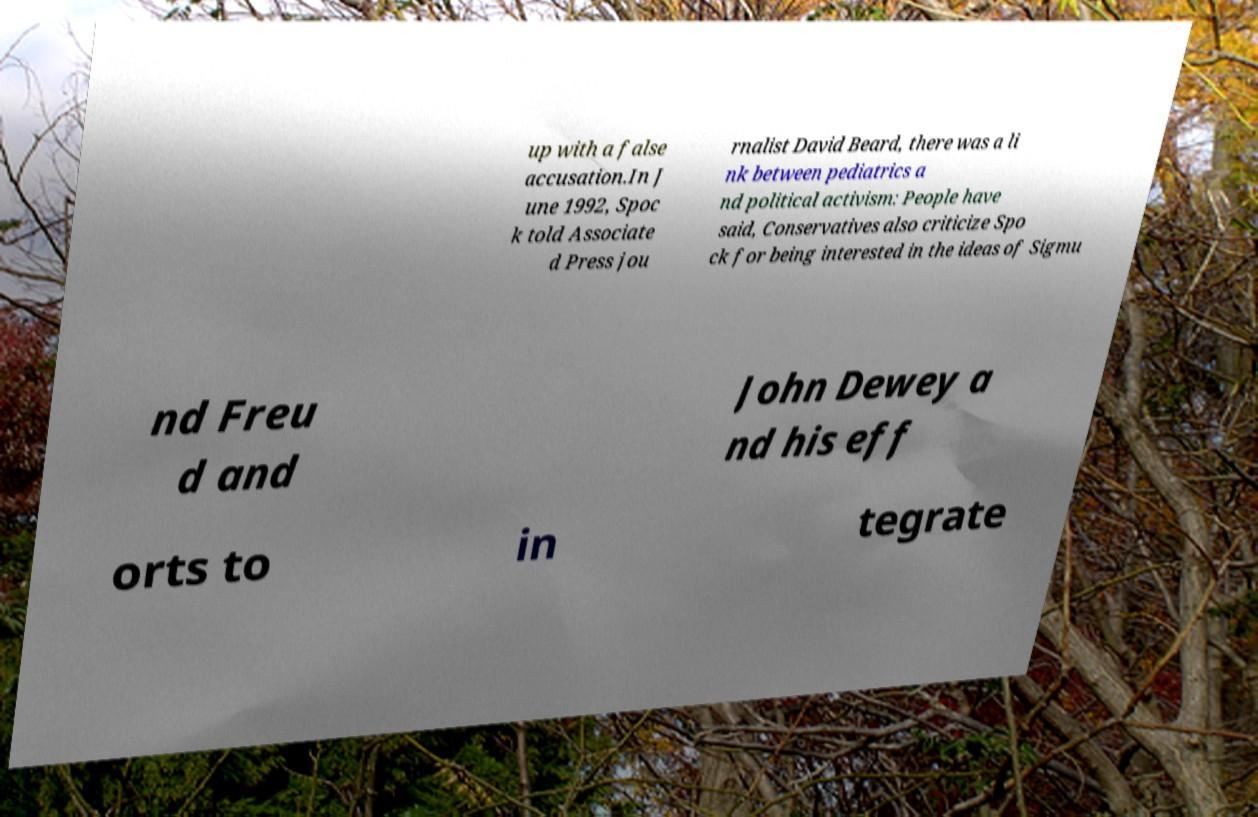Could you assist in decoding the text presented in this image and type it out clearly? up with a false accusation.In J une 1992, Spoc k told Associate d Press jou rnalist David Beard, there was a li nk between pediatrics a nd political activism: People have said, Conservatives also criticize Spo ck for being interested in the ideas of Sigmu nd Freu d and John Dewey a nd his eff orts to in tegrate 